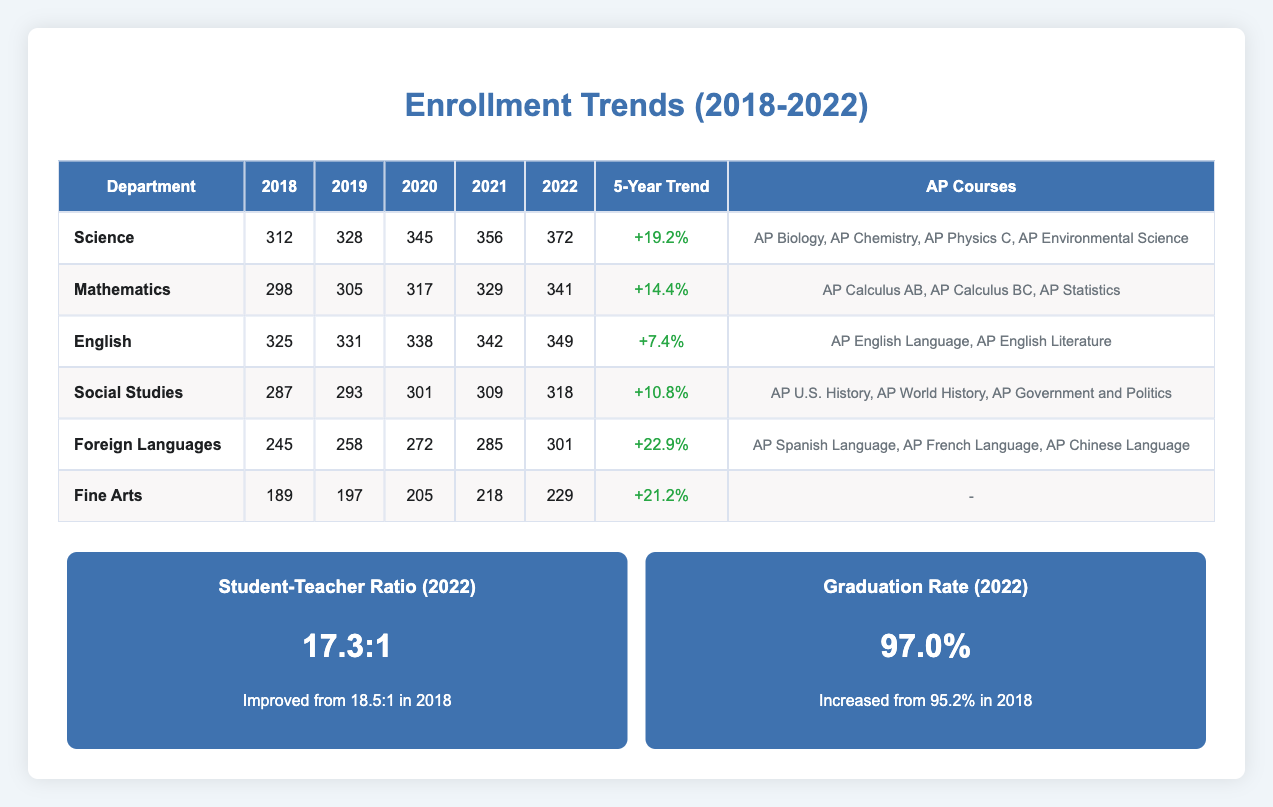What was the enrollment in the Science department in 2020? According to the table, the enrollment for the Science department in 2020 is listed as 345.
Answer: 345 Which department had the highest enrollment in 2022? In 2022, the Science department had the highest enrollment of 372 compared to the other departments listed in the table.
Answer: Science What was the percentage increase in enrollment for Foreign Languages from 2018 to 2022? The enrollment for Foreign Languages in 2018 was 245 and in 2022 it was 301, leading to an increase of (301 - 245) / 245 * 100 = 22.9%.
Answer: 22.9% Is it true that Fine Arts had any Advanced Placement courses offered? According to the table, the Fine Arts department does not list any Advanced Placement courses, which makes the statement false.
Answer: False What is the average enrollment across all departments in 2021? Adding the enrollments of all departments in 2021 gives 356 (Science) + 329 (Mathematics) + 342 (English) + 309 (Social Studies) + 285 (Foreign Languages) + 218 (Fine Arts) = 1839. Dividing this by the number of departments (6) results in an average of 1839 / 6 = 306.5.
Answer: 306.5 Which department saw the lowest growth percentage over the past 5 years? Comparing the growth percentages for each department, English had the lowest increase at 7.4%, as shown in the table.
Answer: English What was the trend direction for the Mathematics department's enrollments from 2018 to 2022? The enrollments in the Mathematics department increased each year from 298 in 2018 to 341 in 2022, indicating a positive trend in enrollments.
Answer: Upward How much did the overall student-teacher ratio improve from 2018 to 2022? The student-teacher ratio in 2018 was 18.5 and in 2022 it was 17.3, so the improvement amounts to 18.5 - 17.3 = 1.2.
Answer: 1.2 